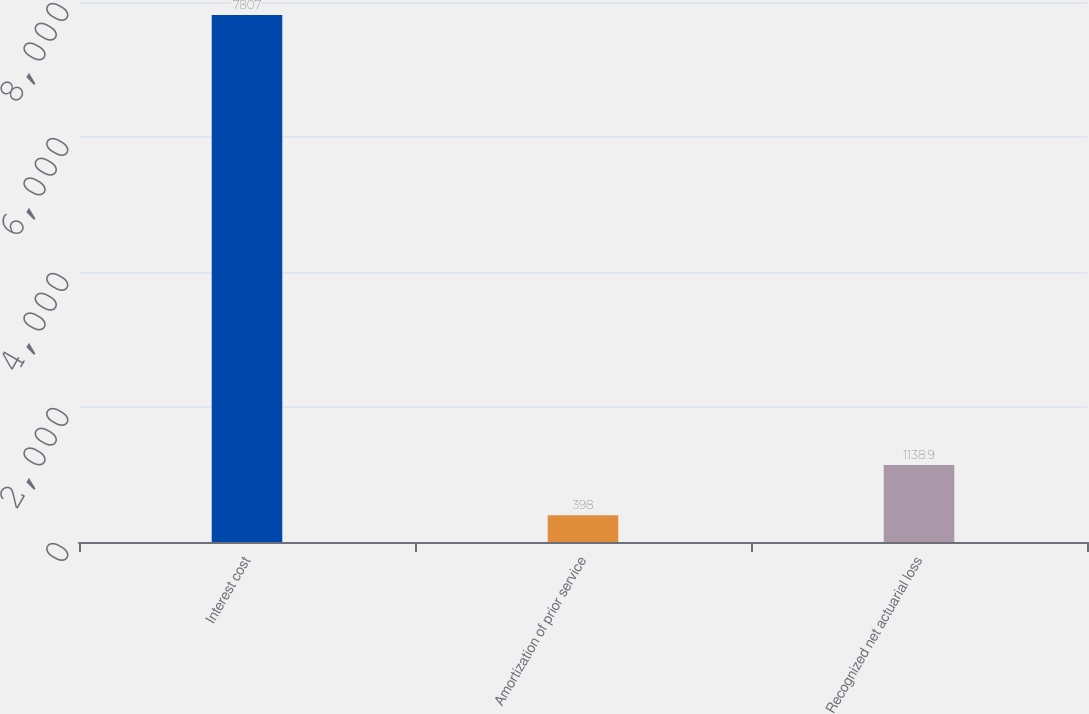Convert chart to OTSL. <chart><loc_0><loc_0><loc_500><loc_500><bar_chart><fcel>Interest cost<fcel>Amortization of prior service<fcel>Recognized net actuarial loss<nl><fcel>7807<fcel>398<fcel>1138.9<nl></chart> 